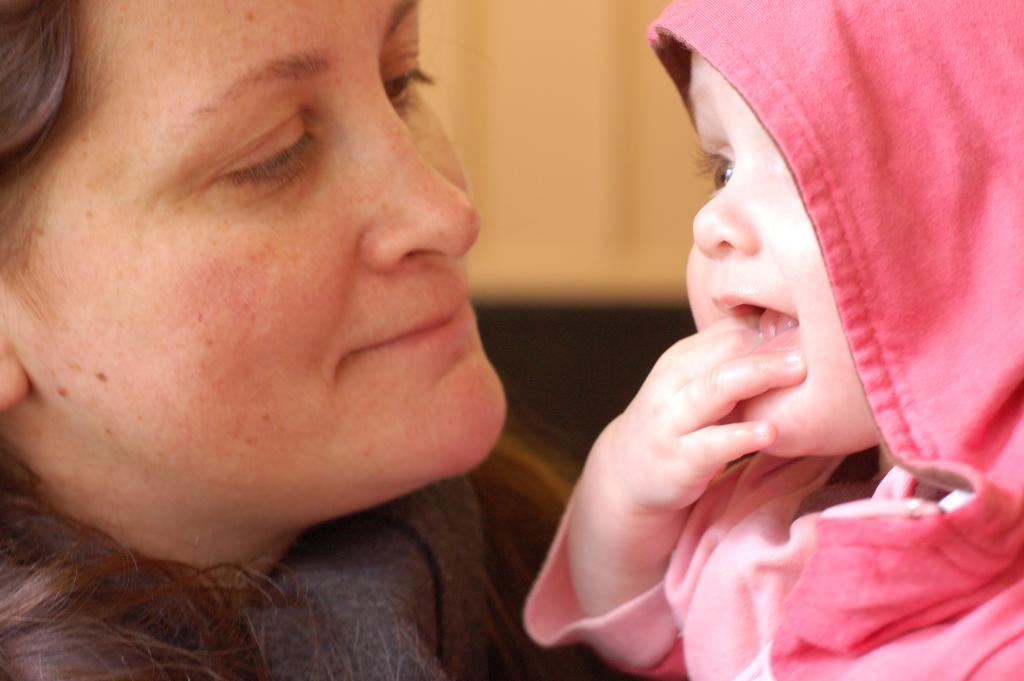In one or two sentences, can you explain what this image depicts? In this image there is a woman on the left side and on the right side there is a kid smiling. 